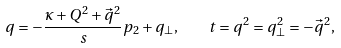<formula> <loc_0><loc_0><loc_500><loc_500>q = - \frac { \kappa + Q ^ { 2 } + \vec { q } ^ { 2 } } { s } p _ { 2 } + q _ { \perp } , \quad t = q ^ { 2 } = q _ { \perp } ^ { 2 } = - \vec { q } ^ { 2 } ,</formula> 